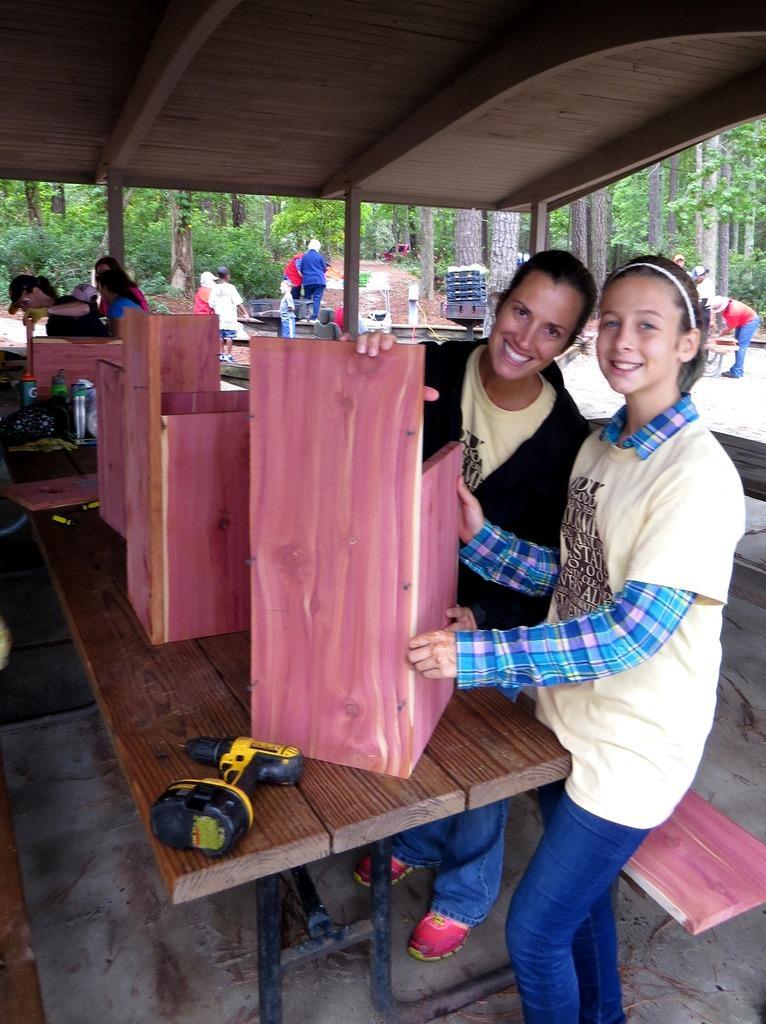Please provide a concise description of this image. This image is taken in outdoors. In this image there are few people standing on the floor. In the right side of the image a woman is standing on the floor, holding a cardboard piece on the table. In the middle of the image there is a table and on top of that there is a drilling machine and wooden pieces on it. In the background there are many trees. At the top of the image is a ceiling. 